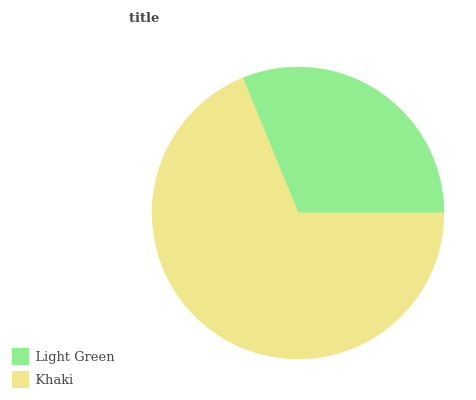Is Light Green the minimum?
Answer yes or no. Yes. Is Khaki the maximum?
Answer yes or no. Yes. Is Khaki the minimum?
Answer yes or no. No. Is Khaki greater than Light Green?
Answer yes or no. Yes. Is Light Green less than Khaki?
Answer yes or no. Yes. Is Light Green greater than Khaki?
Answer yes or no. No. Is Khaki less than Light Green?
Answer yes or no. No. Is Khaki the high median?
Answer yes or no. Yes. Is Light Green the low median?
Answer yes or no. Yes. Is Light Green the high median?
Answer yes or no. No. Is Khaki the low median?
Answer yes or no. No. 